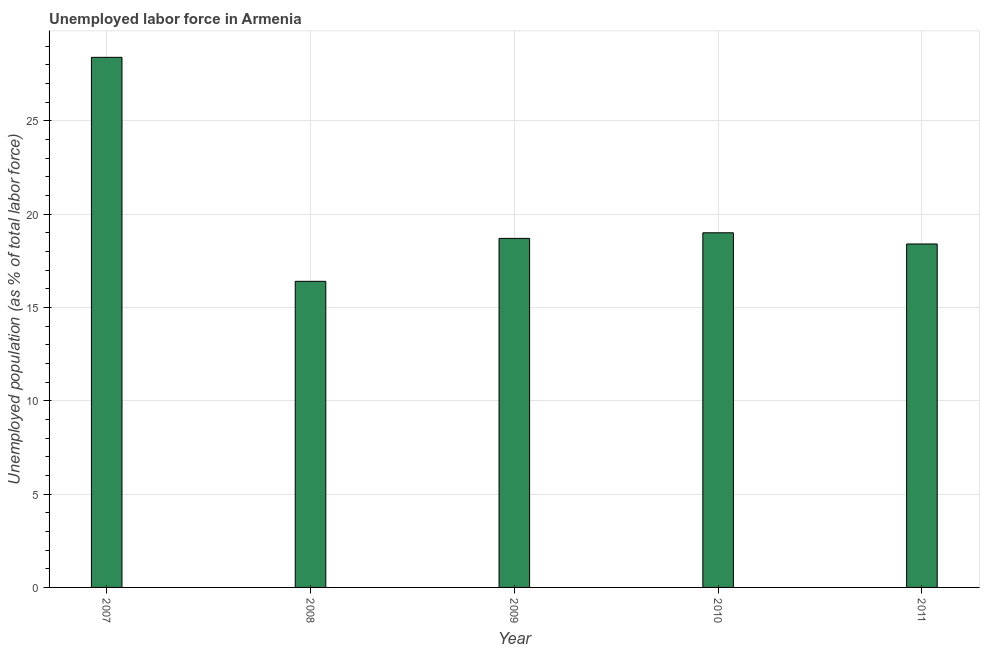Does the graph contain any zero values?
Provide a short and direct response. No. Does the graph contain grids?
Your response must be concise. Yes. What is the title of the graph?
Provide a succinct answer. Unemployed labor force in Armenia. What is the label or title of the Y-axis?
Ensure brevity in your answer.  Unemployed population (as % of total labor force). What is the total unemployed population in 2010?
Your response must be concise. 19. Across all years, what is the maximum total unemployed population?
Provide a succinct answer. 28.4. Across all years, what is the minimum total unemployed population?
Give a very brief answer. 16.4. In which year was the total unemployed population minimum?
Ensure brevity in your answer.  2008. What is the sum of the total unemployed population?
Your answer should be compact. 100.9. What is the difference between the total unemployed population in 2009 and 2011?
Offer a very short reply. 0.3. What is the average total unemployed population per year?
Make the answer very short. 20.18. What is the median total unemployed population?
Your response must be concise. 18.7. In how many years, is the total unemployed population greater than 20 %?
Ensure brevity in your answer.  1. Is the total unemployed population in 2008 less than that in 2011?
Offer a very short reply. Yes. Is the difference between the total unemployed population in 2008 and 2010 greater than the difference between any two years?
Offer a very short reply. No. What is the difference between the highest and the second highest total unemployed population?
Ensure brevity in your answer.  9.4. Are all the bars in the graph horizontal?
Offer a very short reply. No. How many years are there in the graph?
Keep it short and to the point. 5. What is the Unemployed population (as % of total labor force) of 2007?
Provide a short and direct response. 28.4. What is the Unemployed population (as % of total labor force) of 2008?
Provide a short and direct response. 16.4. What is the Unemployed population (as % of total labor force) in 2009?
Provide a succinct answer. 18.7. What is the Unemployed population (as % of total labor force) in 2011?
Provide a short and direct response. 18.4. What is the difference between the Unemployed population (as % of total labor force) in 2007 and 2008?
Your answer should be very brief. 12. What is the difference between the Unemployed population (as % of total labor force) in 2008 and 2010?
Your answer should be compact. -2.6. What is the difference between the Unemployed population (as % of total labor force) in 2009 and 2010?
Offer a very short reply. -0.3. What is the difference between the Unemployed population (as % of total labor force) in 2009 and 2011?
Your answer should be compact. 0.3. What is the ratio of the Unemployed population (as % of total labor force) in 2007 to that in 2008?
Your response must be concise. 1.73. What is the ratio of the Unemployed population (as % of total labor force) in 2007 to that in 2009?
Provide a short and direct response. 1.52. What is the ratio of the Unemployed population (as % of total labor force) in 2007 to that in 2010?
Your response must be concise. 1.5. What is the ratio of the Unemployed population (as % of total labor force) in 2007 to that in 2011?
Offer a terse response. 1.54. What is the ratio of the Unemployed population (as % of total labor force) in 2008 to that in 2009?
Your answer should be compact. 0.88. What is the ratio of the Unemployed population (as % of total labor force) in 2008 to that in 2010?
Offer a very short reply. 0.86. What is the ratio of the Unemployed population (as % of total labor force) in 2008 to that in 2011?
Your answer should be compact. 0.89. What is the ratio of the Unemployed population (as % of total labor force) in 2009 to that in 2010?
Your response must be concise. 0.98. What is the ratio of the Unemployed population (as % of total labor force) in 2010 to that in 2011?
Your answer should be compact. 1.03. 